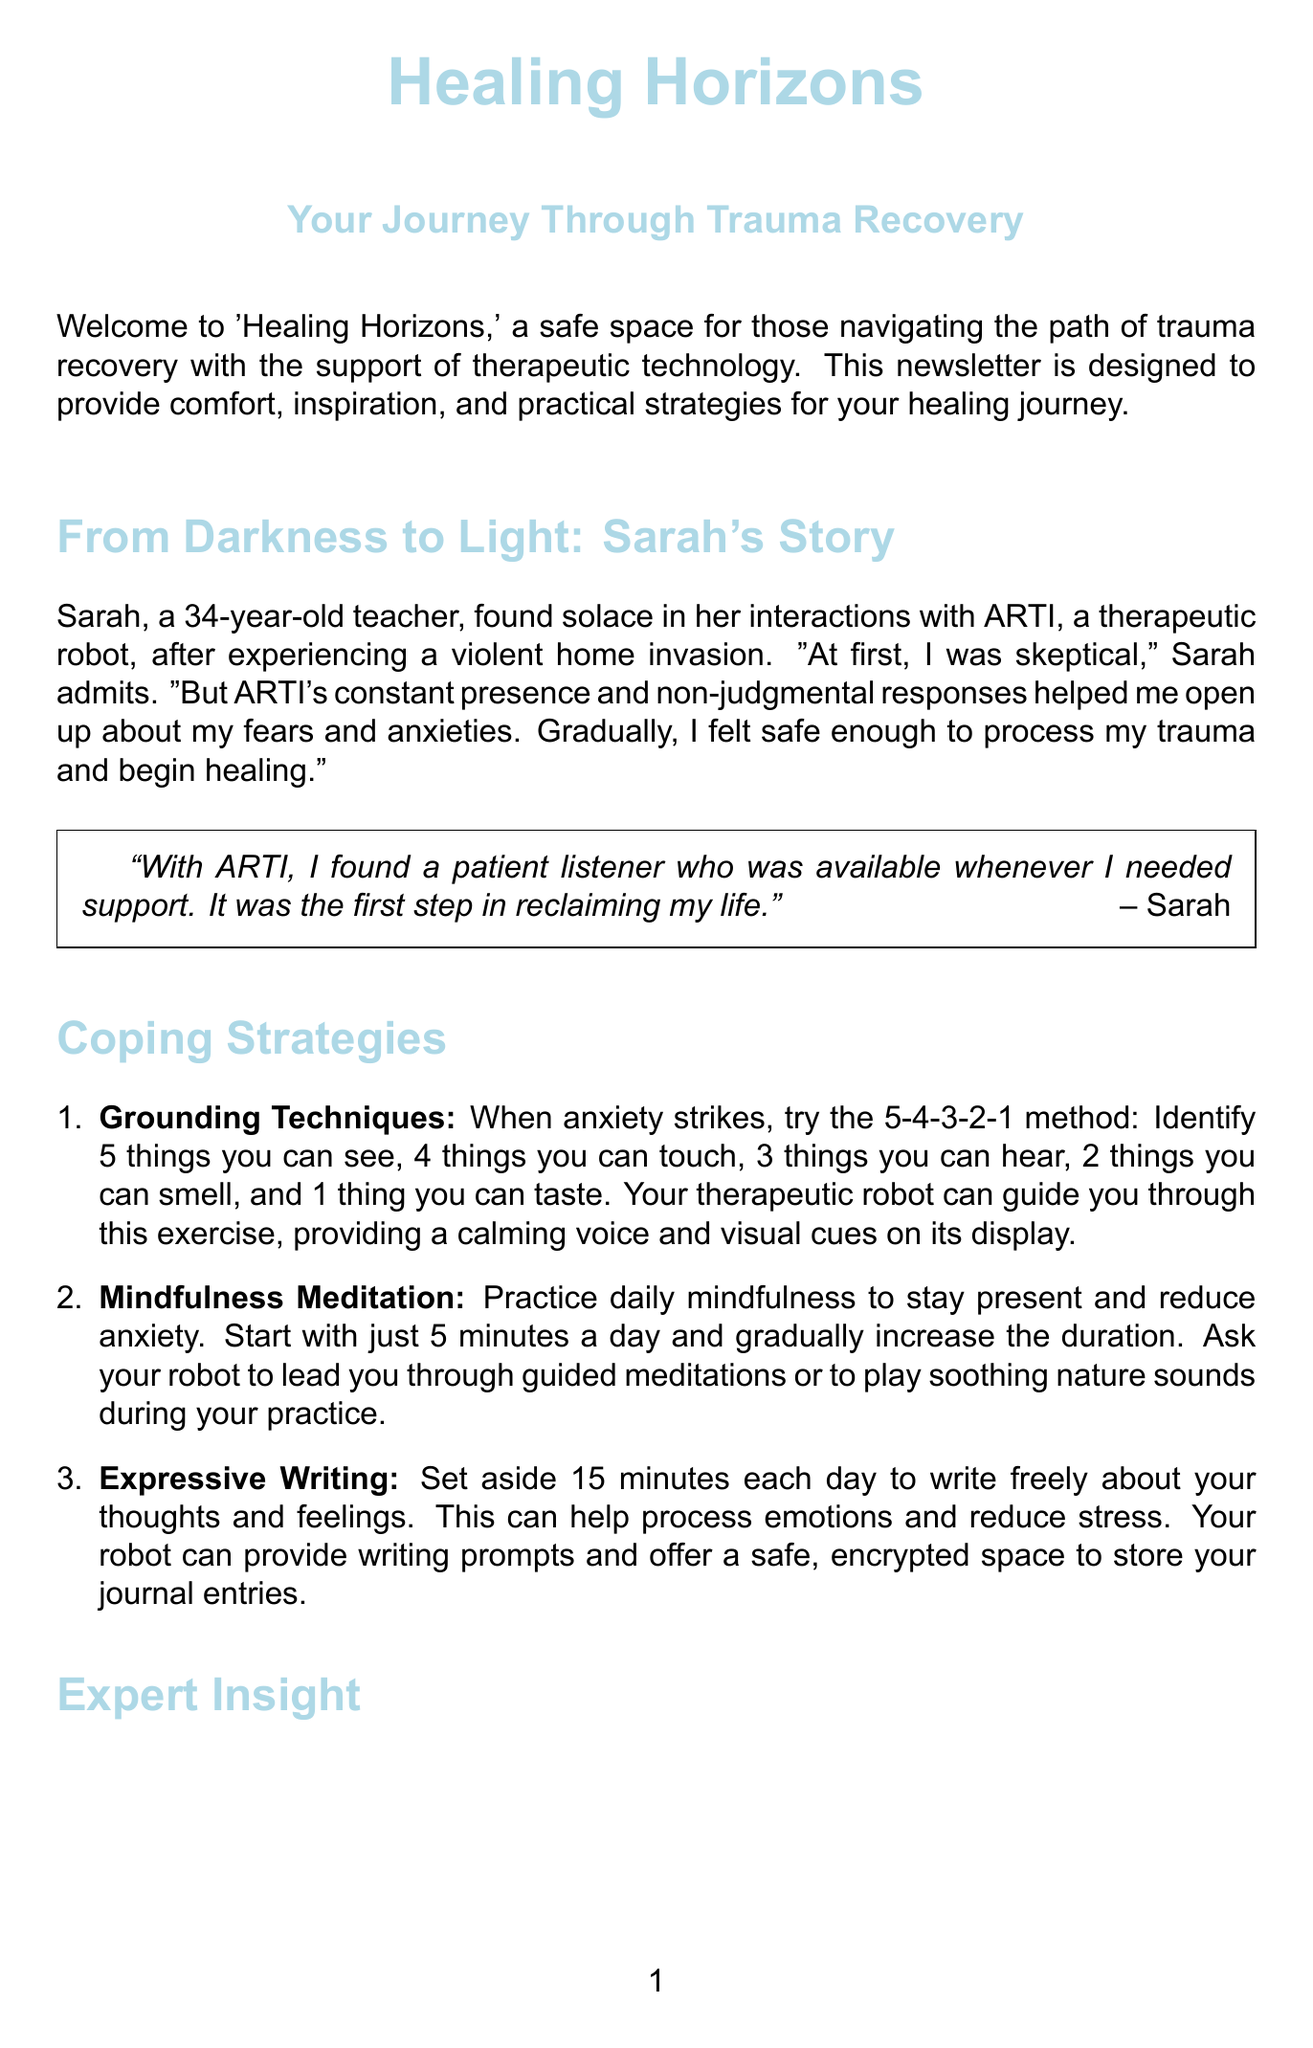what is the title of the newsletter? The title is explicitly mentioned at the beginning of the document, highlighting the focus on trauma recovery.
Answer: Healing Horizons: Your Journey Through Trauma Recovery who shared their personal account in the newsletter? The document features a story from an individual who underwent a traumatic experience, showcasing personal healing.
Answer: Sarah what coping strategy involves identifying sensory experiences? The document outlines various coping strategies, mentioning specific methods to handle anxiety.
Answer: Grounding Techniques how often does the virtual support group meet? The meeting frequency for the support group is specified, giving readers information on when to join.
Answer: Every Wednesday who is the expert quoted in the newsletter? The document references a professional in the mental health field offering insights into trauma recovery.
Answer: Dr. Emily Chen what book is spotlighted as a resource in the newsletter? The document highlights a specific book that provides valuable information regarding trauma and recovery.
Answer: The Body Keeps the Score what is one suggested activity for self-care? The document gives recommendations for reconnecting with joyful activities from childhood as part of self-care.
Answer: Coloring what advice is offered about the healing process? The document emphasizes an important perspective on the nature of healing, focusing on the experience.
Answer: Healing is not linear 